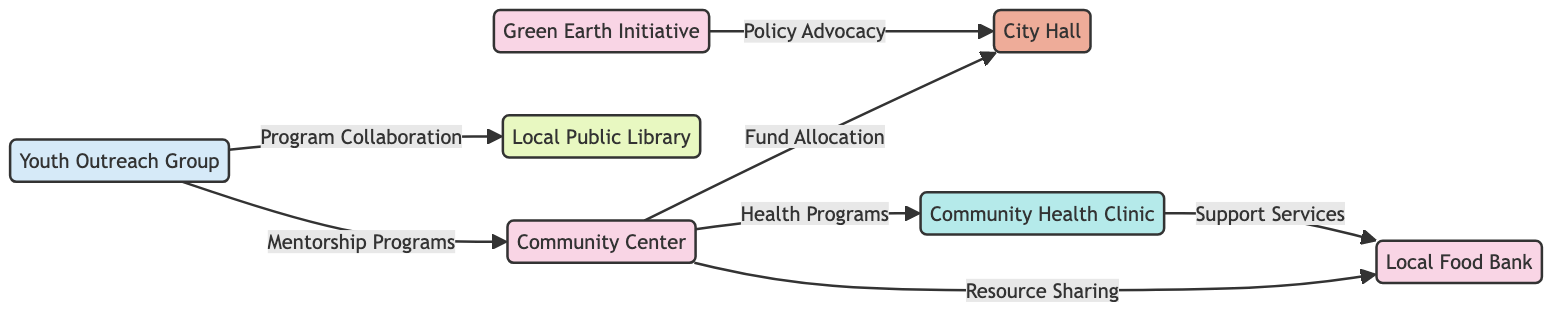What is the type of the "Community Center"? The "Community Center" is classified as a "Non-Profit Organization" in the diagram. This is indicated in the node's attributes section, where the type is clearly defined.
Answer: Non-Profit Organization How many nodes are there in the diagram? By counting each unique node listed in the data, we find there are a total of 7 nodes, including the Community Center, Local Food Bank, City Hall, Youth Outreach Group, Local Public Library, Green Earth Initiative, and Community Health Clinic.
Answer: 7 What type of connection does "City Hall" have with "Community Center"? The connection between "City Hall" and "Community Center" is a "Fund Allocation". This is explicitly described in the connections section where the relationship type is stated clearly.
Answer: Fund Allocation Which organization collaborates with the "Local Public Library"? The "Youth Outreach Group" is the organization that collaborates with the "Local Public Library" for educational programs, as indicated in the connection details provided in the diagram.
Answer: Youth Outreach Group What is the total number of connections in the diagram? There are 7 connections listed in the connections data, which detail the relationships between the various nodes within the diagram.
Answer: 7 What is the relationship type between "Community Health Clinic" and "Local Food Bank"? The relationship type between these two organizations is "Support Services", which is defined in the connections that outline the nature of their collaboration.
Answer: Support Services Which agencies are connected to "City Hall"? "Community Center" and "Green Earth Initiative" are the two organizations that establish connections with "City Hall", evident from the corresponding connection entries in the diagram.
Answer: Community Center, Green Earth Initiative What type of organization is "Green Earth Initiative"? The "Green Earth Initiative" is categorized as a "Non-Profit Organization" in the diagram, as indicated in the information pertaining to that node.
Answer: Non-Profit Organization Which node has the connection type "Resource Sharing"? The "Resource Sharing" connection type is between "Community Center" and "Local Food Bank", as mentioned in the connection details in the diagram.
Answer: Community Center, Local Food Bank 